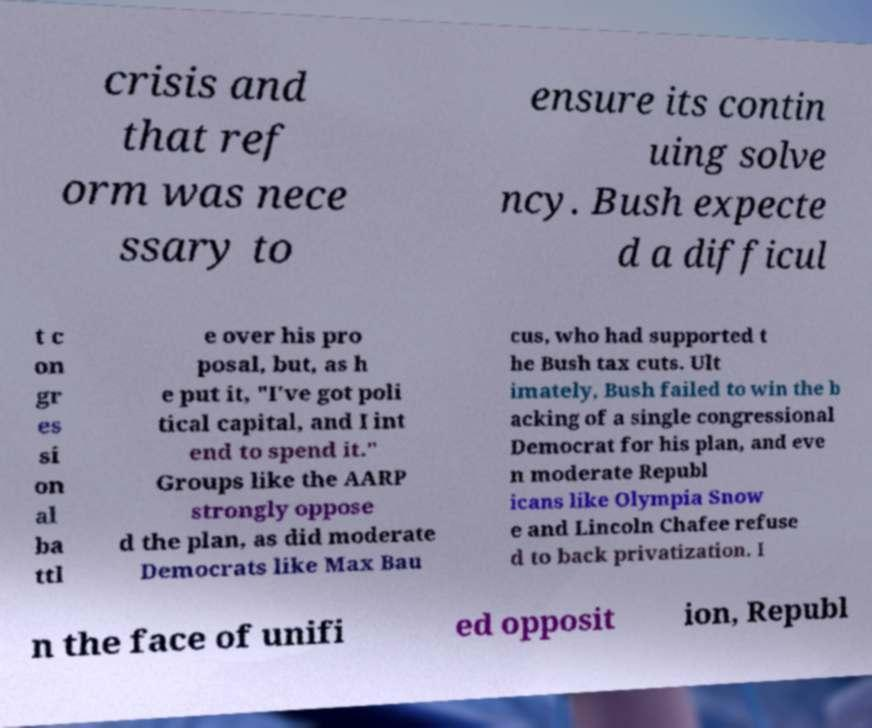Please identify and transcribe the text found in this image. crisis and that ref orm was nece ssary to ensure its contin uing solve ncy. Bush expecte d a difficul t c on gr es si on al ba ttl e over his pro posal, but, as h e put it, "I've got poli tical capital, and I int end to spend it." Groups like the AARP strongly oppose d the plan, as did moderate Democrats like Max Bau cus, who had supported t he Bush tax cuts. Ult imately, Bush failed to win the b acking of a single congressional Democrat for his plan, and eve n moderate Republ icans like Olympia Snow e and Lincoln Chafee refuse d to back privatization. I n the face of unifi ed opposit ion, Republ 